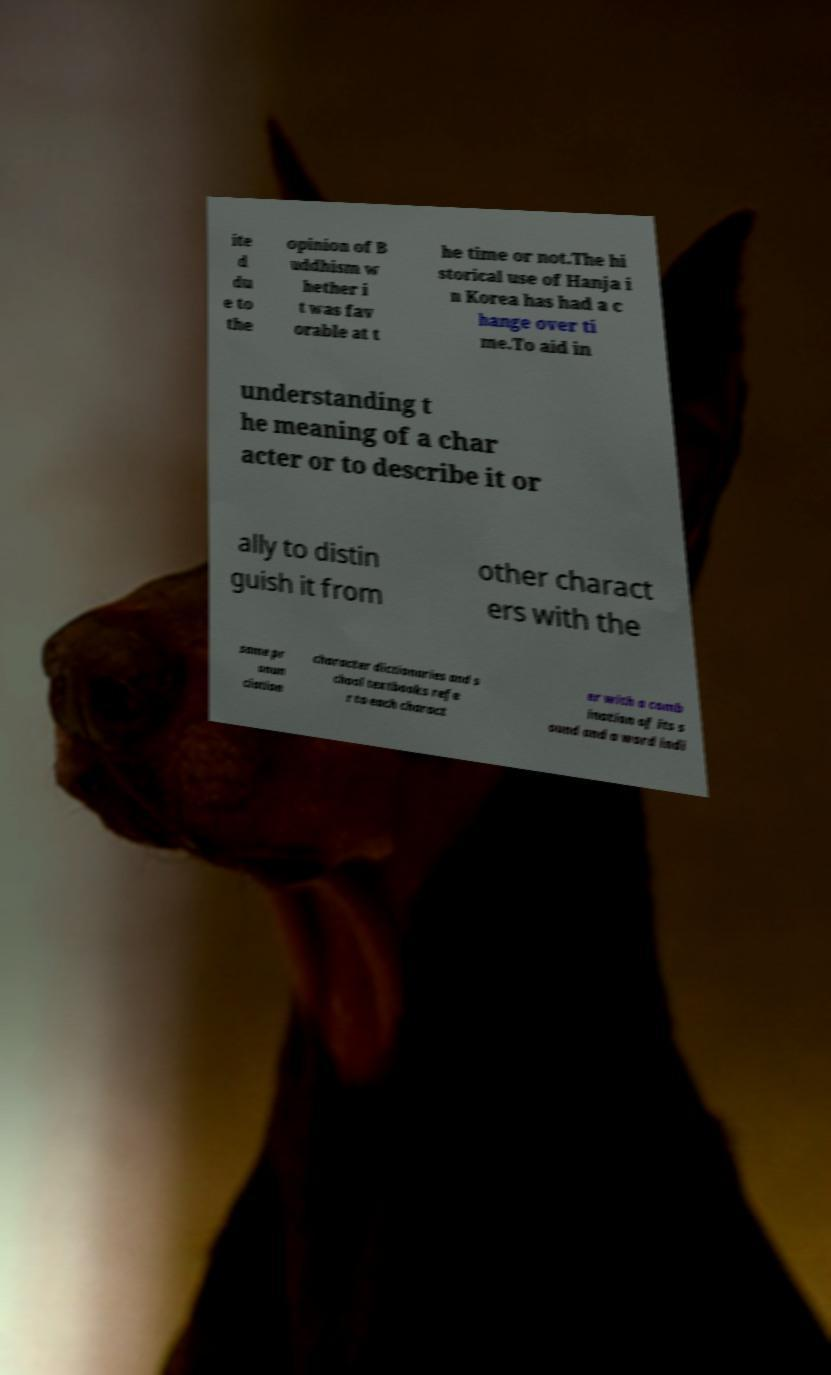There's text embedded in this image that I need extracted. Can you transcribe it verbatim? ite d du e to the opinion of B uddhism w hether i t was fav orable at t he time or not.The hi storical use of Hanja i n Korea has had a c hange over ti me.To aid in understanding t he meaning of a char acter or to describe it or ally to distin guish it from other charact ers with the same pr onun ciation character dictionaries and s chool textbooks refe r to each charact er with a comb ination of its s ound and a word indi 